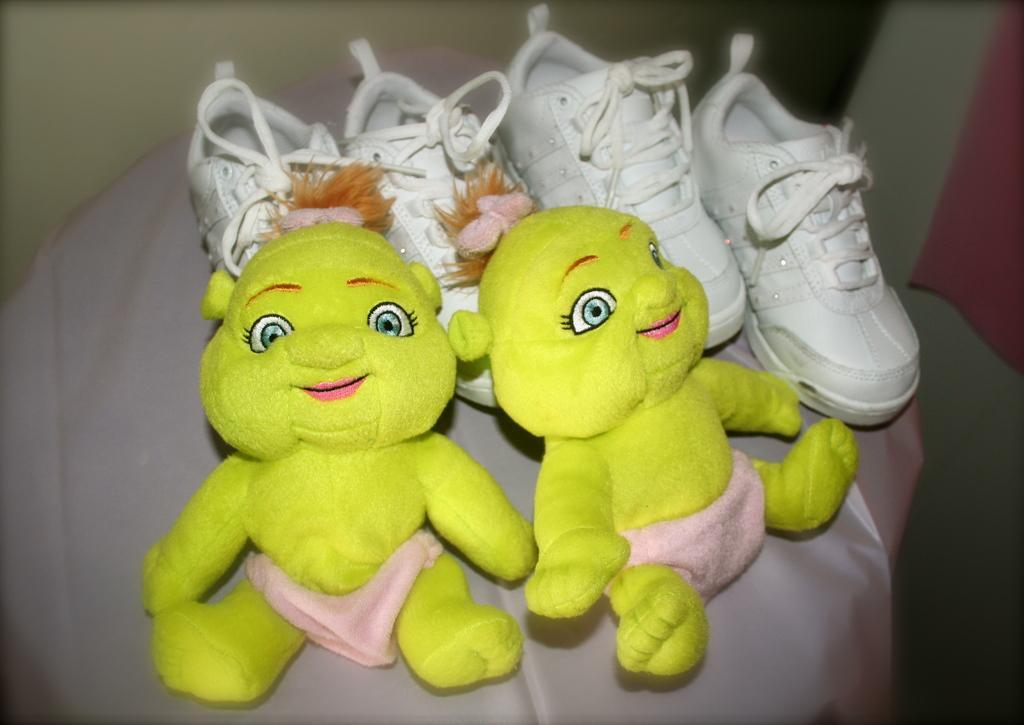Can you describe this image briefly? In this image there are two yellow dolls behind them there are two pairs of white shoes on the cloth. 